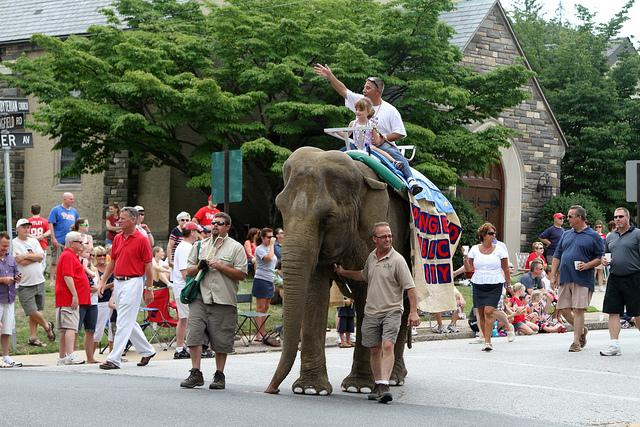What is the long fabric item hanging down the elephant's side? banner 